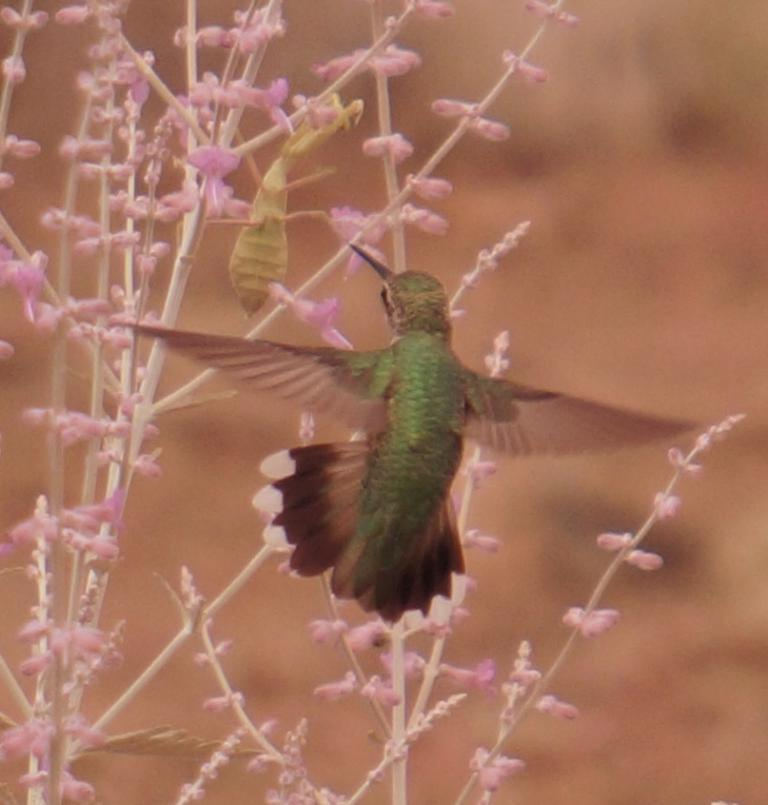What type of animals can be seen in the image? There are birds in the middle of the image. What kind of plants are present in the image? There are plants with flowers in the image. Can you describe the background of the image? The background of the image is blurred. What type of account is being discussed in the image? There is no account being discussed in the image; it features birds and plants with flowers. Can you hear the birds singing in the image? The image is not an audio or video recording, so it is not possible to hear the birds singing. 